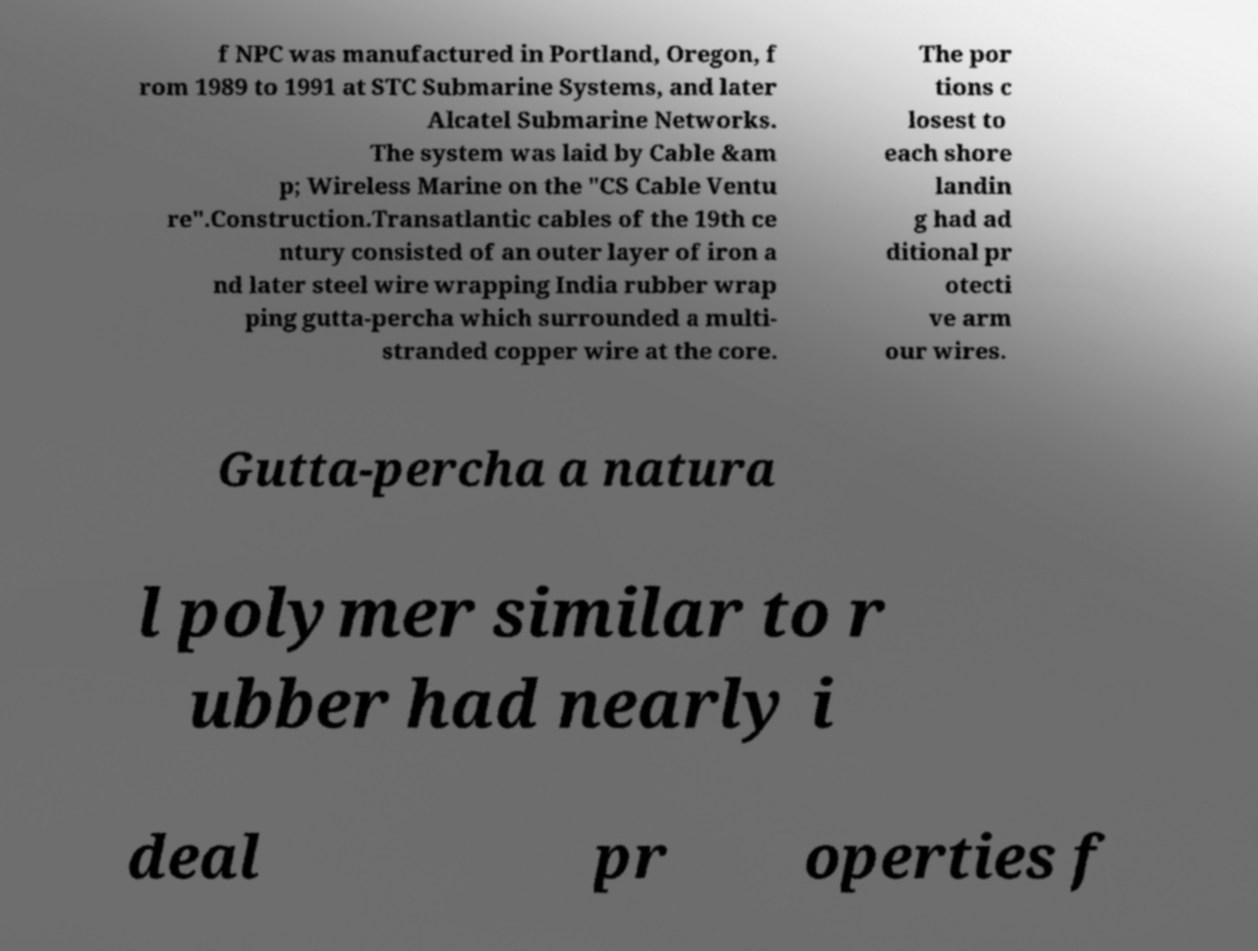What messages or text are displayed in this image? I need them in a readable, typed format. f NPC was manufactured in Portland, Oregon, f rom 1989 to 1991 at STC Submarine Systems, and later Alcatel Submarine Networks. The system was laid by Cable &am p; Wireless Marine on the "CS Cable Ventu re".Construction.Transatlantic cables of the 19th ce ntury consisted of an outer layer of iron a nd later steel wire wrapping India rubber wrap ping gutta-percha which surrounded a multi- stranded copper wire at the core. The por tions c losest to each shore landin g had ad ditional pr otecti ve arm our wires. Gutta-percha a natura l polymer similar to r ubber had nearly i deal pr operties f 